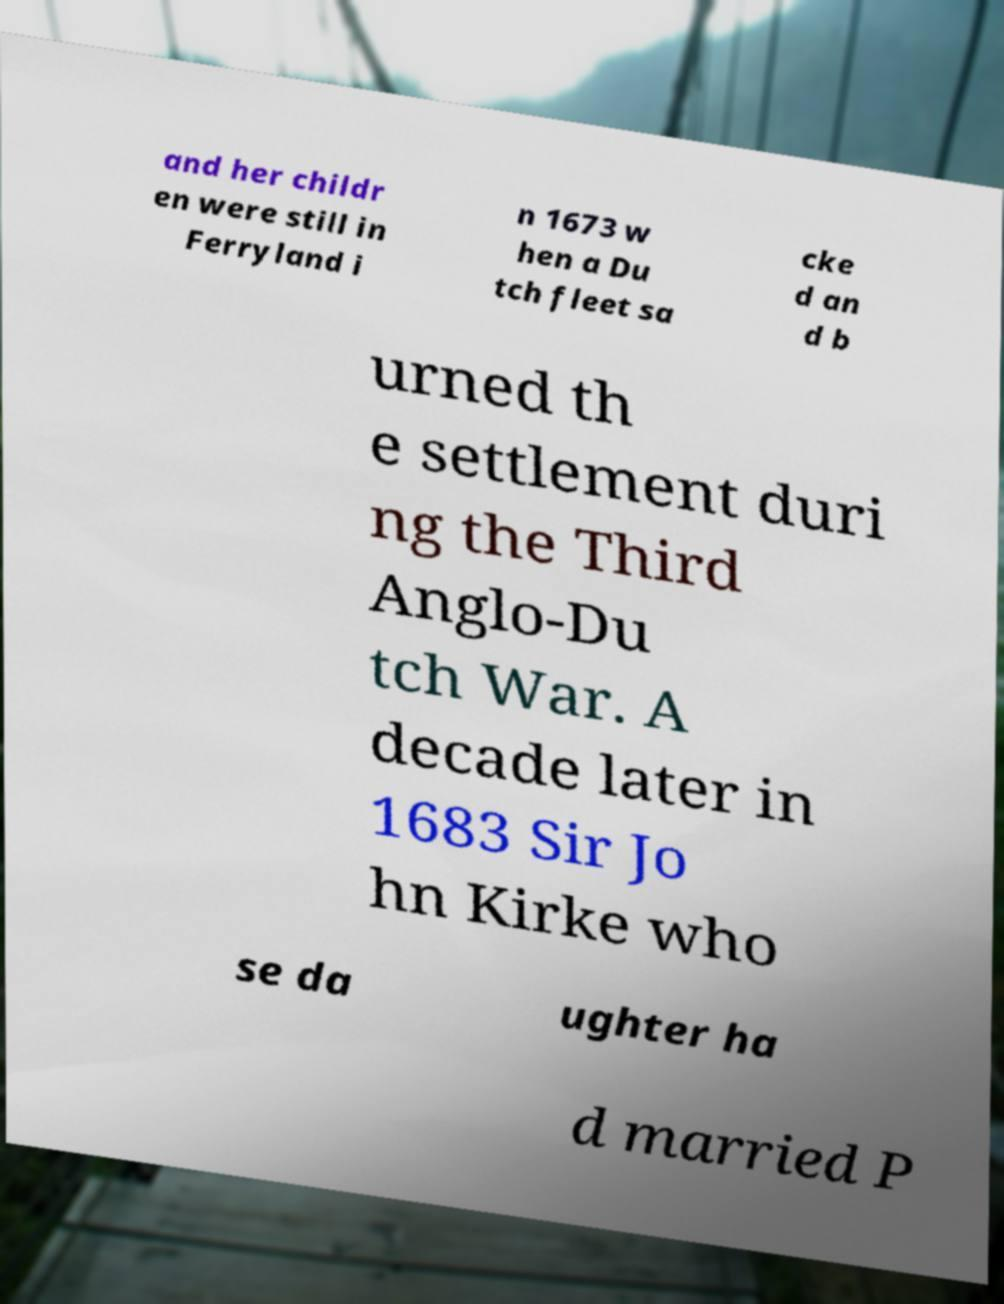I need the written content from this picture converted into text. Can you do that? and her childr en were still in Ferryland i n 1673 w hen a Du tch fleet sa cke d an d b urned th e settlement duri ng the Third Anglo-Du tch War. A decade later in 1683 Sir Jo hn Kirke who se da ughter ha d married P 